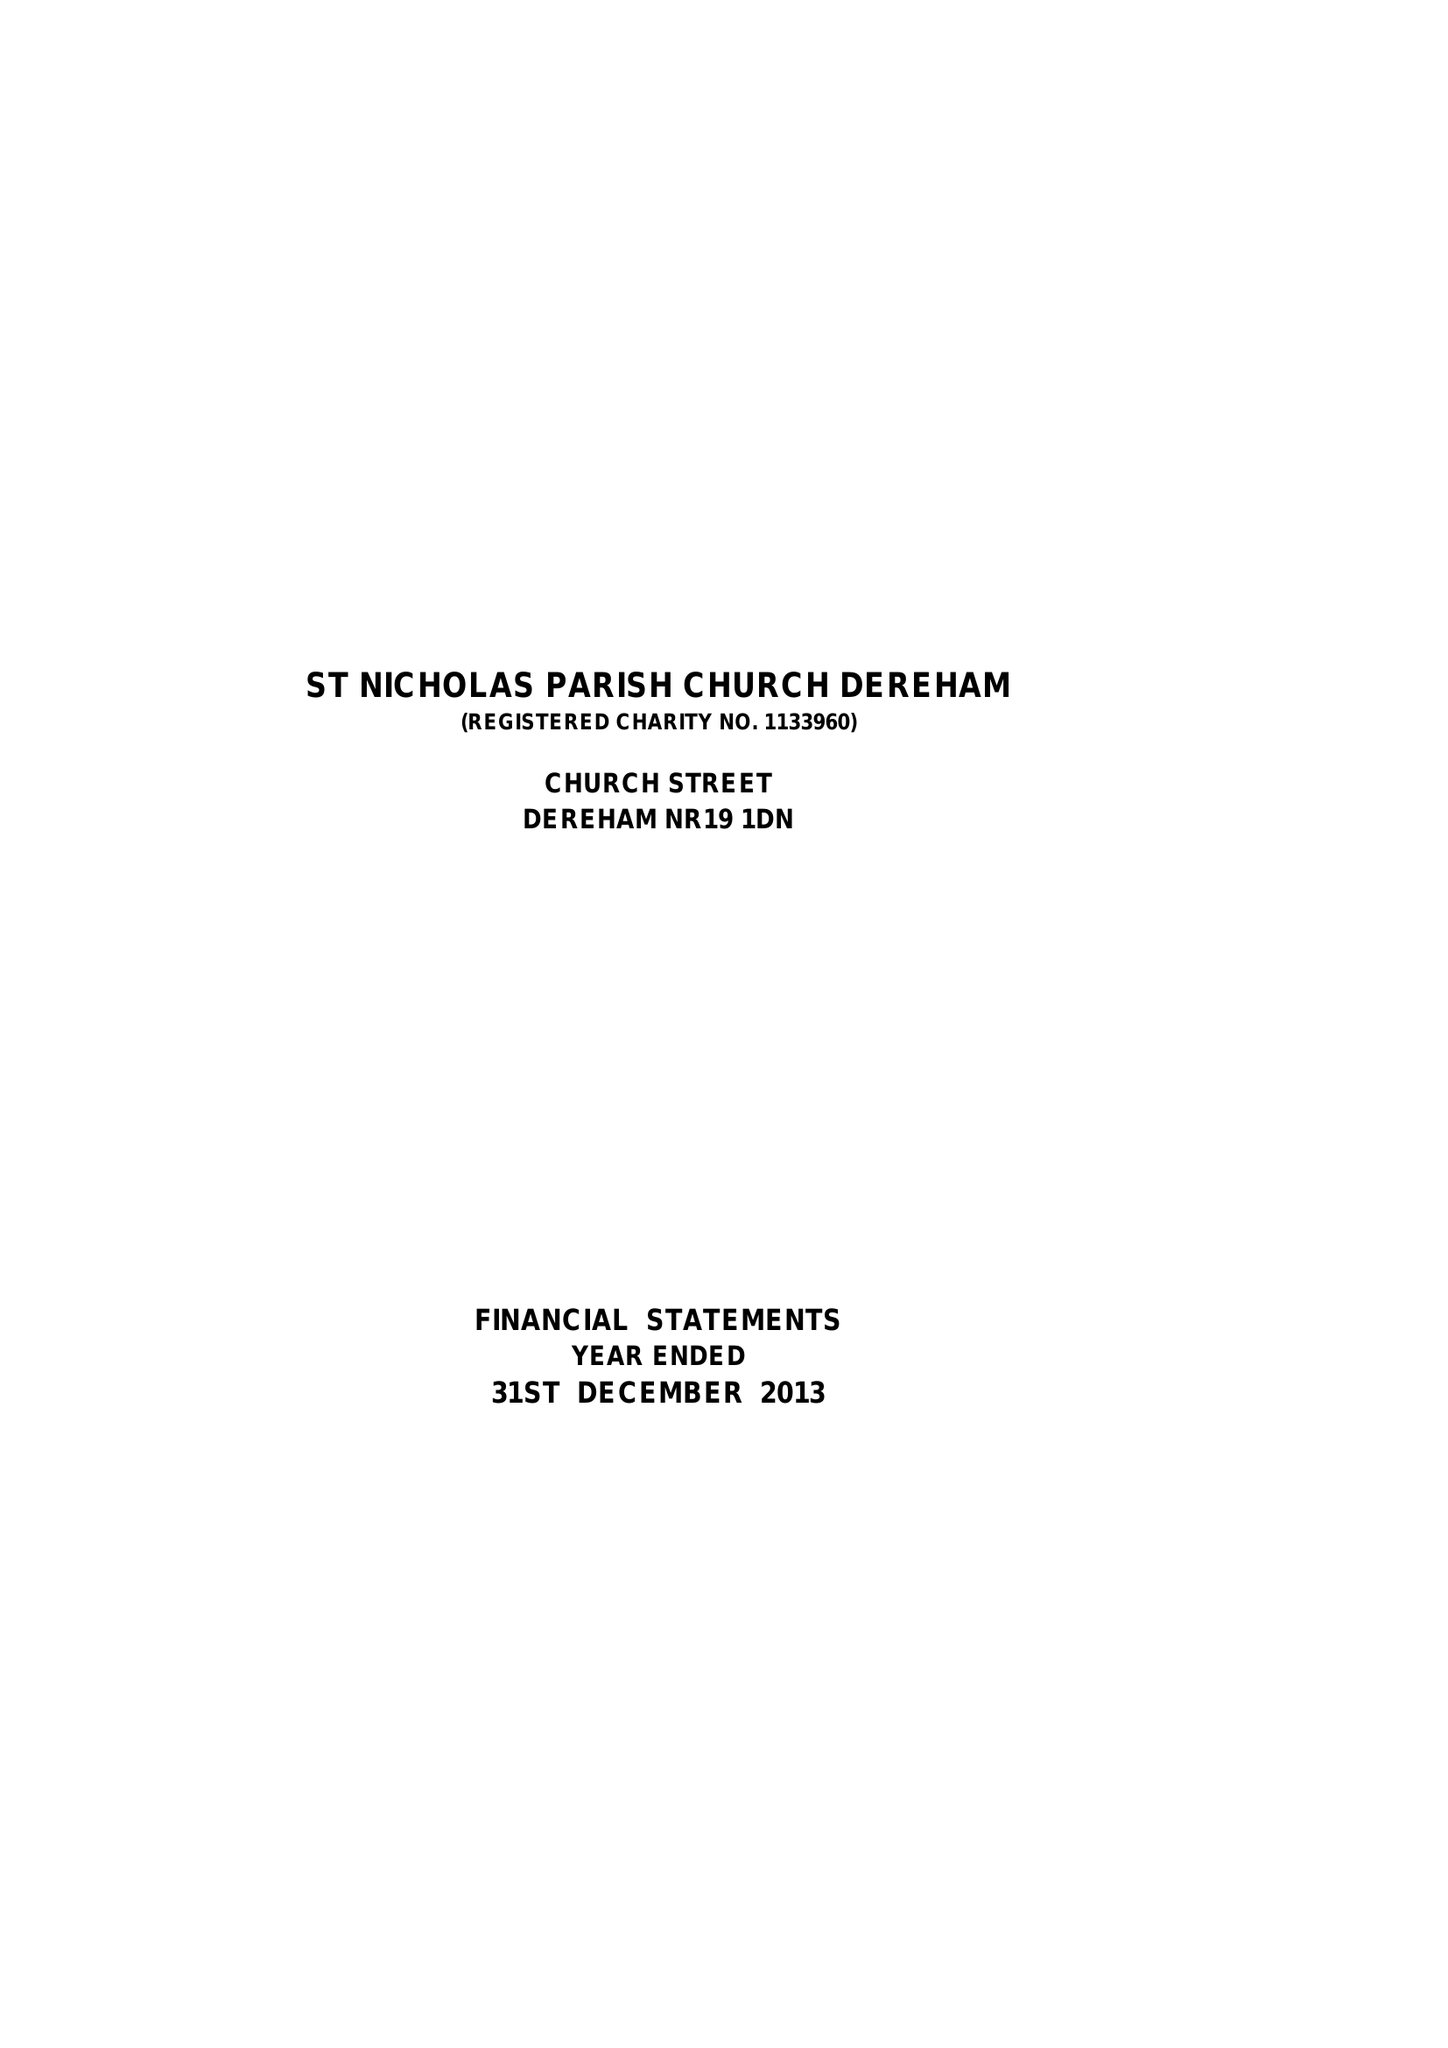What is the value for the address__postcode?
Answer the question using a single word or phrase. NR19 1DN 